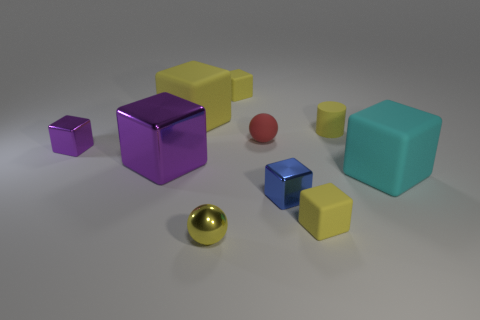How many yellow blocks must be subtracted to get 1 yellow blocks? 2 Subtract all green spheres. How many yellow blocks are left? 3 Subtract all blue blocks. How many blocks are left? 6 Subtract all small yellow matte cubes. How many cubes are left? 5 Subtract all cyan cubes. Subtract all cyan balls. How many cubes are left? 6 Subtract all blocks. How many objects are left? 3 Add 5 matte balls. How many matte balls are left? 6 Add 10 big shiny cylinders. How many big shiny cylinders exist? 10 Subtract 1 yellow cylinders. How many objects are left? 9 Subtract all large rubber blocks. Subtract all large yellow cubes. How many objects are left? 7 